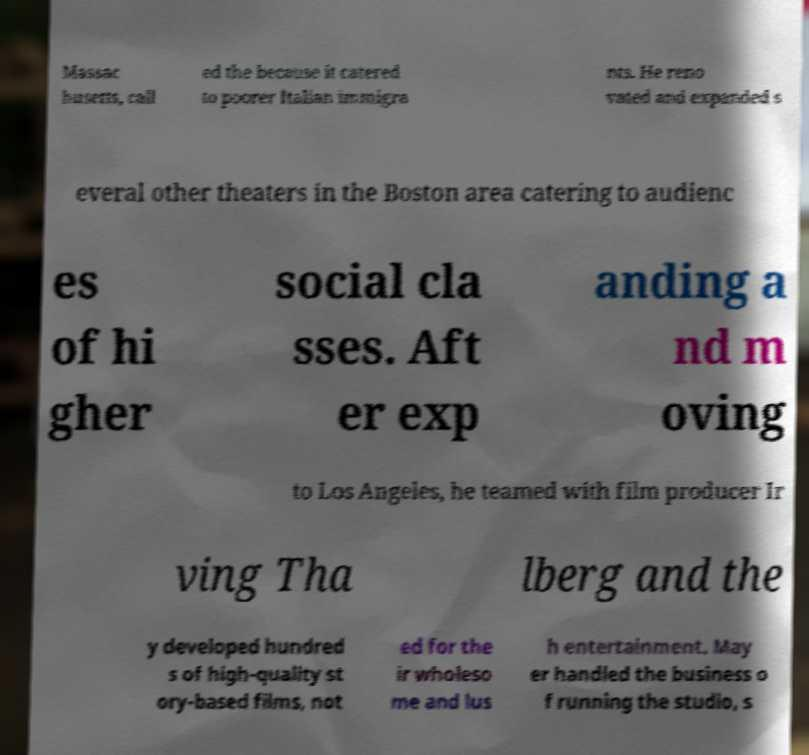What messages or text are displayed in this image? I need them in a readable, typed format. Massac husetts, call ed the because it catered to poorer Italian immigra nts. He reno vated and expanded s everal other theaters in the Boston area catering to audienc es of hi gher social cla sses. Aft er exp anding a nd m oving to Los Angeles, he teamed with film producer Ir ving Tha lberg and the y developed hundred s of high-quality st ory-based films, not ed for the ir wholeso me and lus h entertainment. May er handled the business o f running the studio, s 